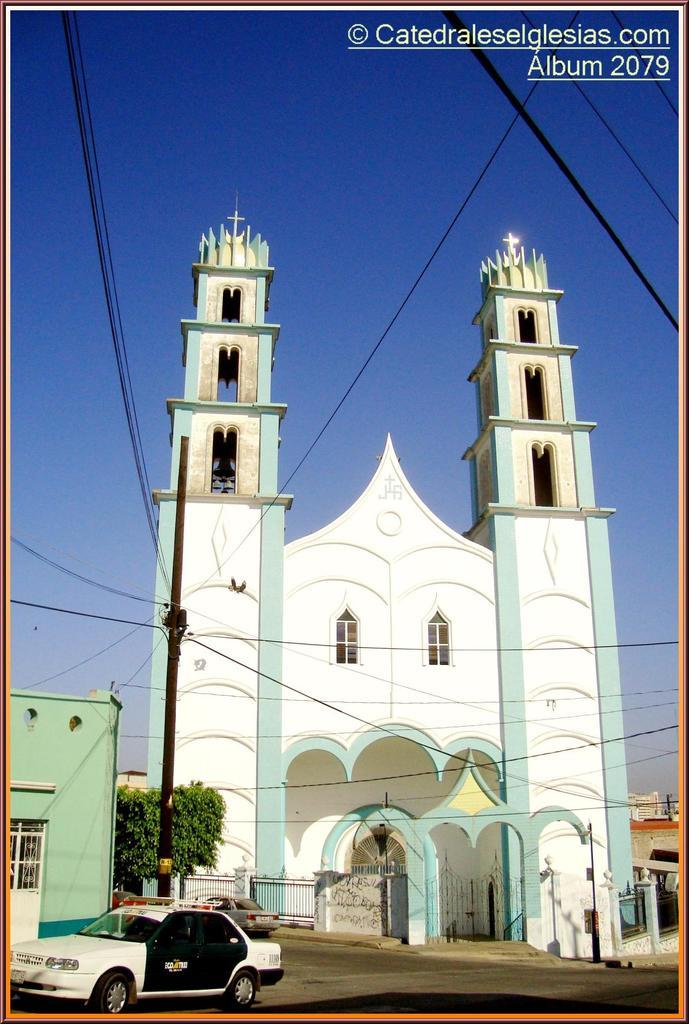<image>
Describe the image concisely. A cathedral that is seafoam green and white is documented in album number 2079. 